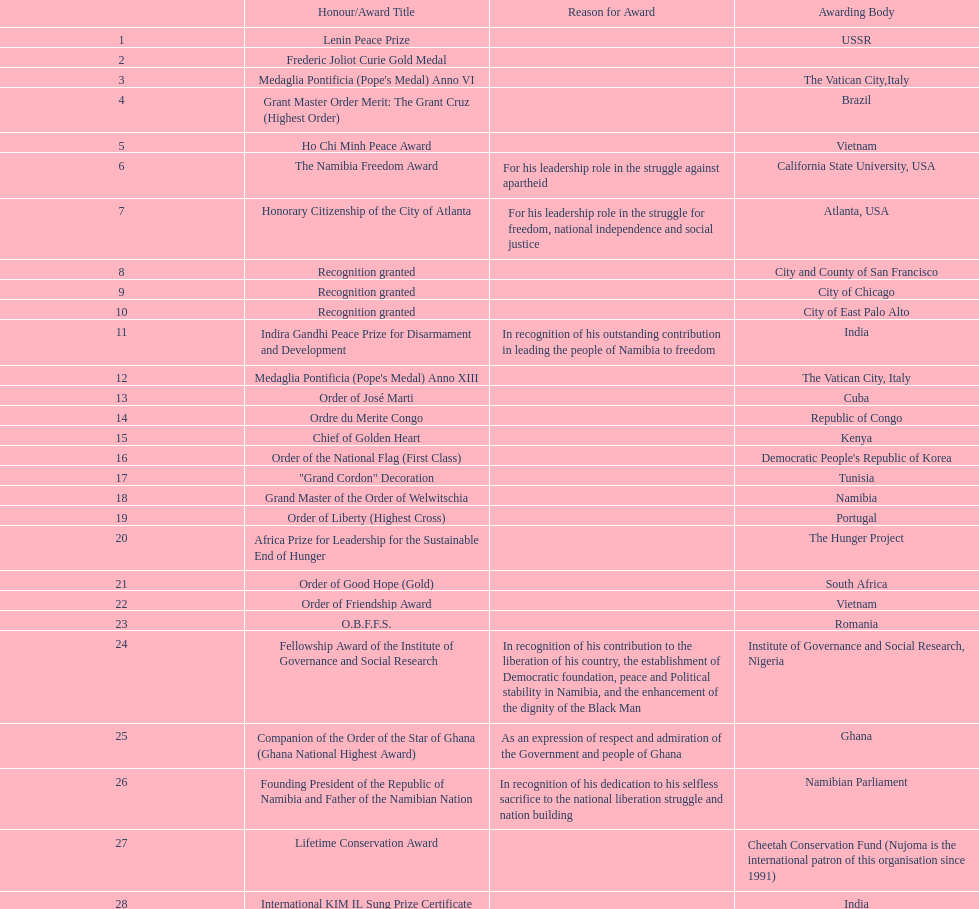What were the total number of honors/award titles listed according to this chart? 29. 